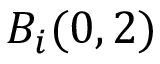<formula> <loc_0><loc_0><loc_500><loc_500>B _ { i } ( 0 , 2 )</formula> 